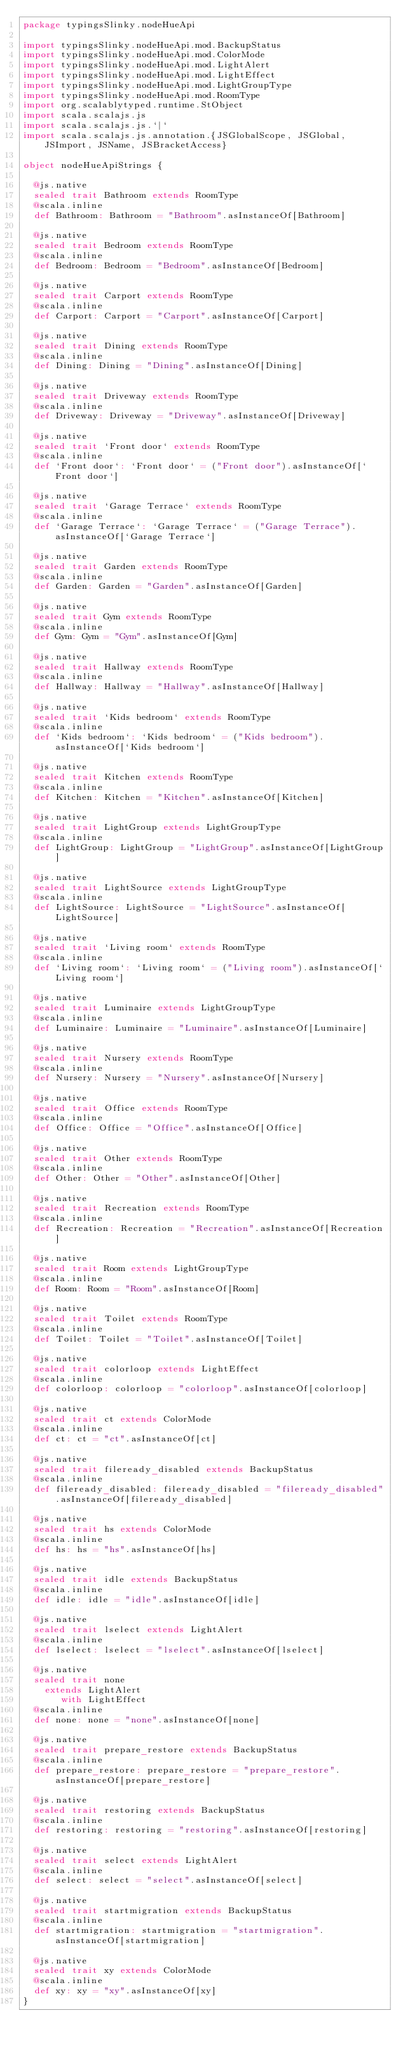<code> <loc_0><loc_0><loc_500><loc_500><_Scala_>package typingsSlinky.nodeHueApi

import typingsSlinky.nodeHueApi.mod.BackupStatus
import typingsSlinky.nodeHueApi.mod.ColorMode
import typingsSlinky.nodeHueApi.mod.LightAlert
import typingsSlinky.nodeHueApi.mod.LightEffect
import typingsSlinky.nodeHueApi.mod.LightGroupType
import typingsSlinky.nodeHueApi.mod.RoomType
import org.scalablytyped.runtime.StObject
import scala.scalajs.js
import scala.scalajs.js.`|`
import scala.scalajs.js.annotation.{JSGlobalScope, JSGlobal, JSImport, JSName, JSBracketAccess}

object nodeHueApiStrings {
  
  @js.native
  sealed trait Bathroom extends RoomType
  @scala.inline
  def Bathroom: Bathroom = "Bathroom".asInstanceOf[Bathroom]
  
  @js.native
  sealed trait Bedroom extends RoomType
  @scala.inline
  def Bedroom: Bedroom = "Bedroom".asInstanceOf[Bedroom]
  
  @js.native
  sealed trait Carport extends RoomType
  @scala.inline
  def Carport: Carport = "Carport".asInstanceOf[Carport]
  
  @js.native
  sealed trait Dining extends RoomType
  @scala.inline
  def Dining: Dining = "Dining".asInstanceOf[Dining]
  
  @js.native
  sealed trait Driveway extends RoomType
  @scala.inline
  def Driveway: Driveway = "Driveway".asInstanceOf[Driveway]
  
  @js.native
  sealed trait `Front door` extends RoomType
  @scala.inline
  def `Front door`: `Front door` = ("Front door").asInstanceOf[`Front door`]
  
  @js.native
  sealed trait `Garage Terrace` extends RoomType
  @scala.inline
  def `Garage Terrace`: `Garage Terrace` = ("Garage Terrace").asInstanceOf[`Garage Terrace`]
  
  @js.native
  sealed trait Garden extends RoomType
  @scala.inline
  def Garden: Garden = "Garden".asInstanceOf[Garden]
  
  @js.native
  sealed trait Gym extends RoomType
  @scala.inline
  def Gym: Gym = "Gym".asInstanceOf[Gym]
  
  @js.native
  sealed trait Hallway extends RoomType
  @scala.inline
  def Hallway: Hallway = "Hallway".asInstanceOf[Hallway]
  
  @js.native
  sealed trait `Kids bedroom` extends RoomType
  @scala.inline
  def `Kids bedroom`: `Kids bedroom` = ("Kids bedroom").asInstanceOf[`Kids bedroom`]
  
  @js.native
  sealed trait Kitchen extends RoomType
  @scala.inline
  def Kitchen: Kitchen = "Kitchen".asInstanceOf[Kitchen]
  
  @js.native
  sealed trait LightGroup extends LightGroupType
  @scala.inline
  def LightGroup: LightGroup = "LightGroup".asInstanceOf[LightGroup]
  
  @js.native
  sealed trait LightSource extends LightGroupType
  @scala.inline
  def LightSource: LightSource = "LightSource".asInstanceOf[LightSource]
  
  @js.native
  sealed trait `Living room` extends RoomType
  @scala.inline
  def `Living room`: `Living room` = ("Living room").asInstanceOf[`Living room`]
  
  @js.native
  sealed trait Luminaire extends LightGroupType
  @scala.inline
  def Luminaire: Luminaire = "Luminaire".asInstanceOf[Luminaire]
  
  @js.native
  sealed trait Nursery extends RoomType
  @scala.inline
  def Nursery: Nursery = "Nursery".asInstanceOf[Nursery]
  
  @js.native
  sealed trait Office extends RoomType
  @scala.inline
  def Office: Office = "Office".asInstanceOf[Office]
  
  @js.native
  sealed trait Other extends RoomType
  @scala.inline
  def Other: Other = "Other".asInstanceOf[Other]
  
  @js.native
  sealed trait Recreation extends RoomType
  @scala.inline
  def Recreation: Recreation = "Recreation".asInstanceOf[Recreation]
  
  @js.native
  sealed trait Room extends LightGroupType
  @scala.inline
  def Room: Room = "Room".asInstanceOf[Room]
  
  @js.native
  sealed trait Toilet extends RoomType
  @scala.inline
  def Toilet: Toilet = "Toilet".asInstanceOf[Toilet]
  
  @js.native
  sealed trait colorloop extends LightEffect
  @scala.inline
  def colorloop: colorloop = "colorloop".asInstanceOf[colorloop]
  
  @js.native
  sealed trait ct extends ColorMode
  @scala.inline
  def ct: ct = "ct".asInstanceOf[ct]
  
  @js.native
  sealed trait fileready_disabled extends BackupStatus
  @scala.inline
  def fileready_disabled: fileready_disabled = "fileready_disabled".asInstanceOf[fileready_disabled]
  
  @js.native
  sealed trait hs extends ColorMode
  @scala.inline
  def hs: hs = "hs".asInstanceOf[hs]
  
  @js.native
  sealed trait idle extends BackupStatus
  @scala.inline
  def idle: idle = "idle".asInstanceOf[idle]
  
  @js.native
  sealed trait lselect extends LightAlert
  @scala.inline
  def lselect: lselect = "lselect".asInstanceOf[lselect]
  
  @js.native
  sealed trait none
    extends LightAlert
       with LightEffect
  @scala.inline
  def none: none = "none".asInstanceOf[none]
  
  @js.native
  sealed trait prepare_restore extends BackupStatus
  @scala.inline
  def prepare_restore: prepare_restore = "prepare_restore".asInstanceOf[prepare_restore]
  
  @js.native
  sealed trait restoring extends BackupStatus
  @scala.inline
  def restoring: restoring = "restoring".asInstanceOf[restoring]
  
  @js.native
  sealed trait select extends LightAlert
  @scala.inline
  def select: select = "select".asInstanceOf[select]
  
  @js.native
  sealed trait startmigration extends BackupStatus
  @scala.inline
  def startmigration: startmigration = "startmigration".asInstanceOf[startmigration]
  
  @js.native
  sealed trait xy extends ColorMode
  @scala.inline
  def xy: xy = "xy".asInstanceOf[xy]
}
</code> 